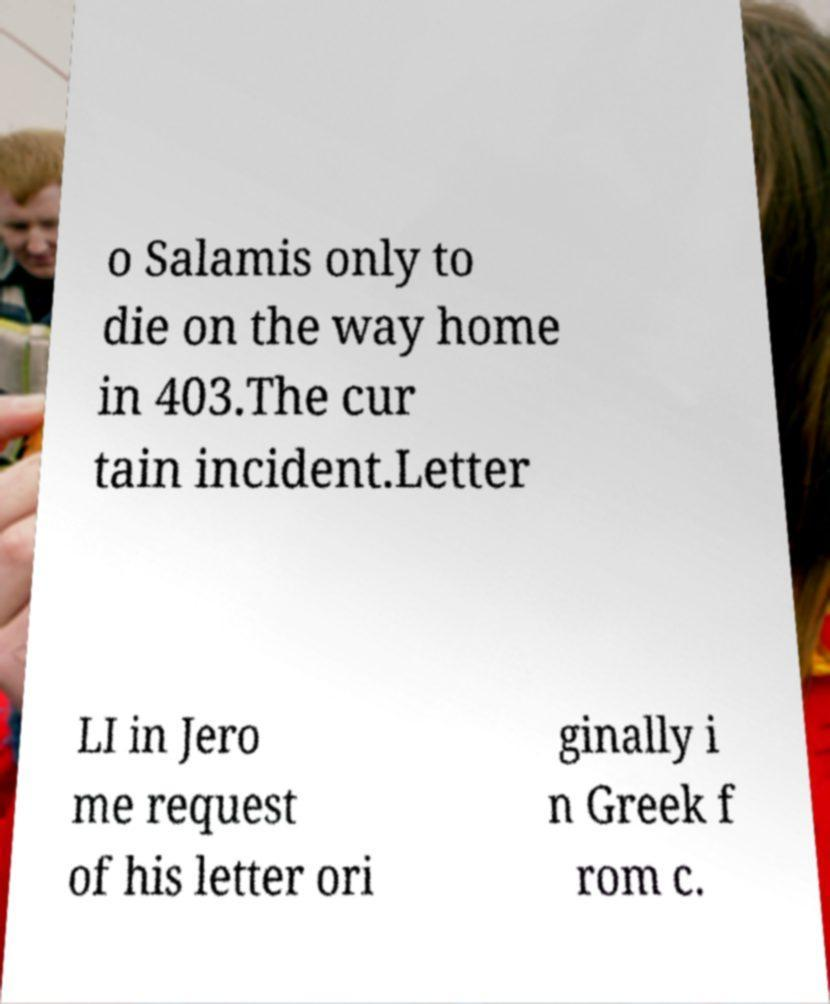Can you accurately transcribe the text from the provided image for me? o Salamis only to die on the way home in 403.The cur tain incident.Letter LI in Jero me request of his letter ori ginally i n Greek f rom c. 